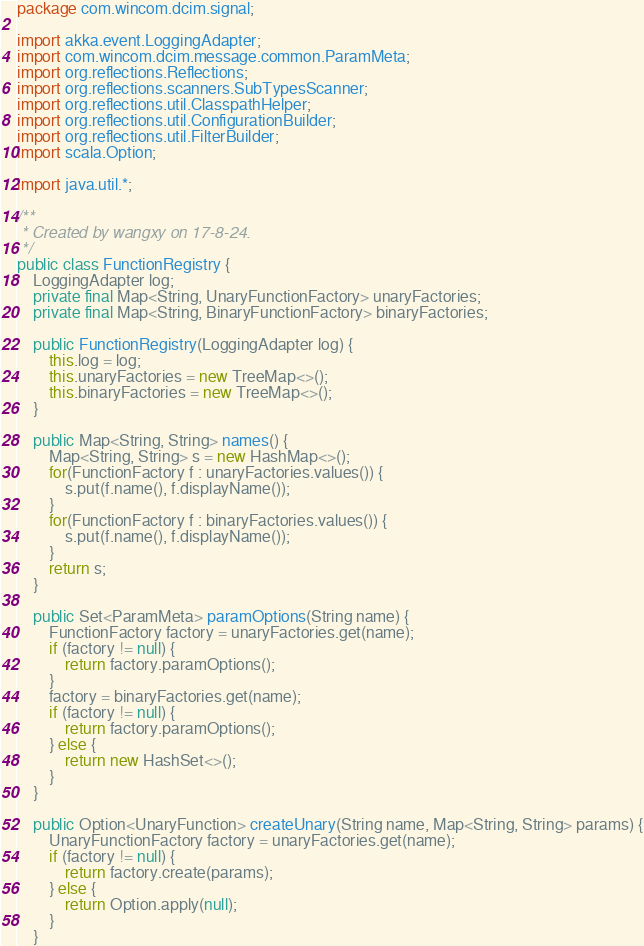<code> <loc_0><loc_0><loc_500><loc_500><_Java_>package com.wincom.dcim.signal;

import akka.event.LoggingAdapter;
import com.wincom.dcim.message.common.ParamMeta;
import org.reflections.Reflections;
import org.reflections.scanners.SubTypesScanner;
import org.reflections.util.ClasspathHelper;
import org.reflections.util.ConfigurationBuilder;
import org.reflections.util.FilterBuilder;
import scala.Option;

import java.util.*;

/**
 * Created by wangxy on 17-8-24.
 */
public class FunctionRegistry {
    LoggingAdapter log;
    private final Map<String, UnaryFunctionFactory> unaryFactories;
    private final Map<String, BinaryFunctionFactory> binaryFactories;

    public FunctionRegistry(LoggingAdapter log) {
        this.log = log;
        this.unaryFactories = new TreeMap<>();
        this.binaryFactories = new TreeMap<>();
    }

    public Map<String, String> names() {
        Map<String, String> s = new HashMap<>();
        for(FunctionFactory f : unaryFactories.values()) {
            s.put(f.name(), f.displayName());
        }
        for(FunctionFactory f : binaryFactories.values()) {
            s.put(f.name(), f.displayName());
        }
        return s;
    }

    public Set<ParamMeta> paramOptions(String name) {
        FunctionFactory factory = unaryFactories.get(name);
        if (factory != null) {
            return factory.paramOptions();
        }
        factory = binaryFactories.get(name);
        if (factory != null) {
            return factory.paramOptions();
        } else {
            return new HashSet<>();
        }
    }

    public Option<UnaryFunction> createUnary(String name, Map<String, String> params) {
        UnaryFunctionFactory factory = unaryFactories.get(name);
        if (factory != null) {
            return factory.create(params);
        } else {
            return Option.apply(null);
        }
    }
</code> 